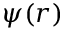Convert formula to latex. <formula><loc_0><loc_0><loc_500><loc_500>\psi ( r )</formula> 